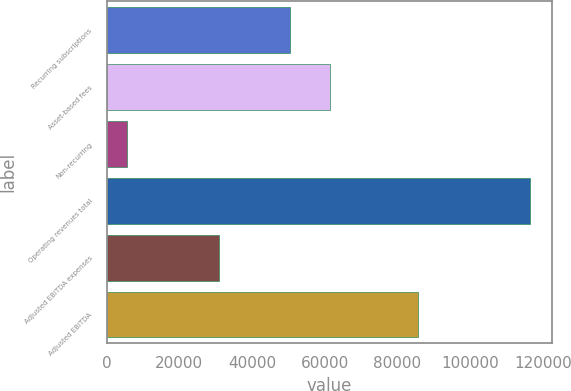Convert chart to OTSL. <chart><loc_0><loc_0><loc_500><loc_500><bar_chart><fcel>Recurring subscriptions<fcel>Asset-based fees<fcel>Non-recurring<fcel>Operating revenues total<fcel>Adjusted EBITDA expenses<fcel>Adjusted EBITDA<nl><fcel>50323<fcel>61402.6<fcel>5720<fcel>116516<fcel>30904<fcel>85612<nl></chart> 